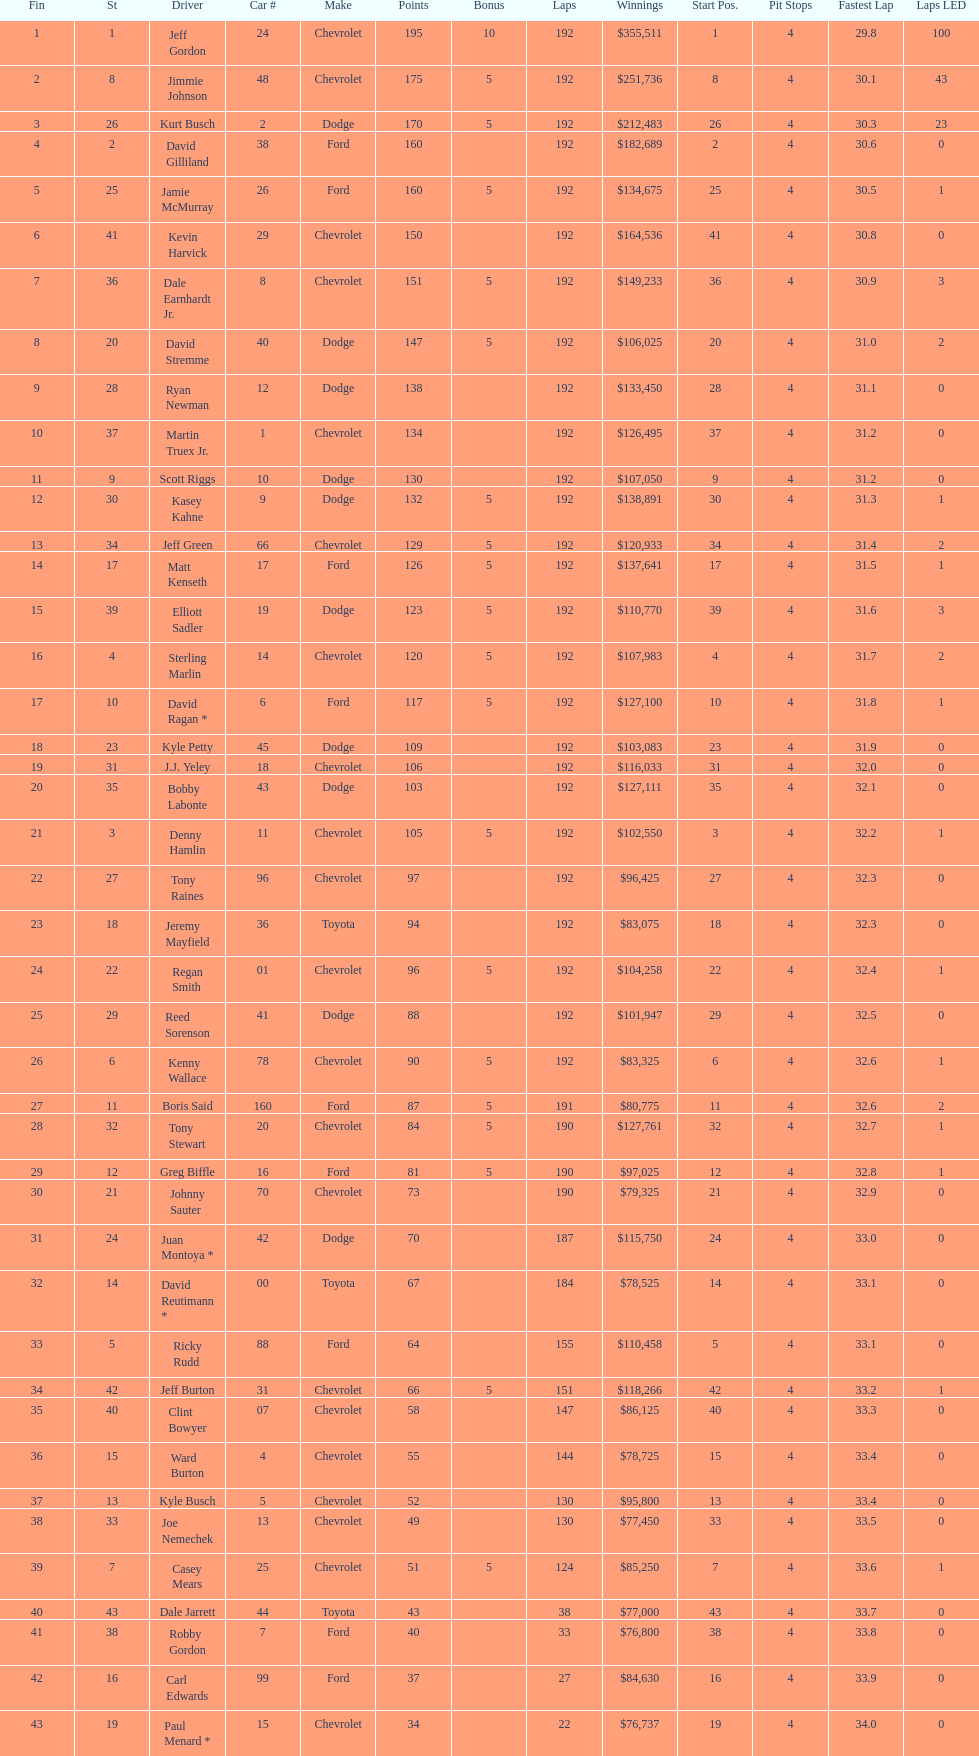What make did kurt busch drive? Dodge. 